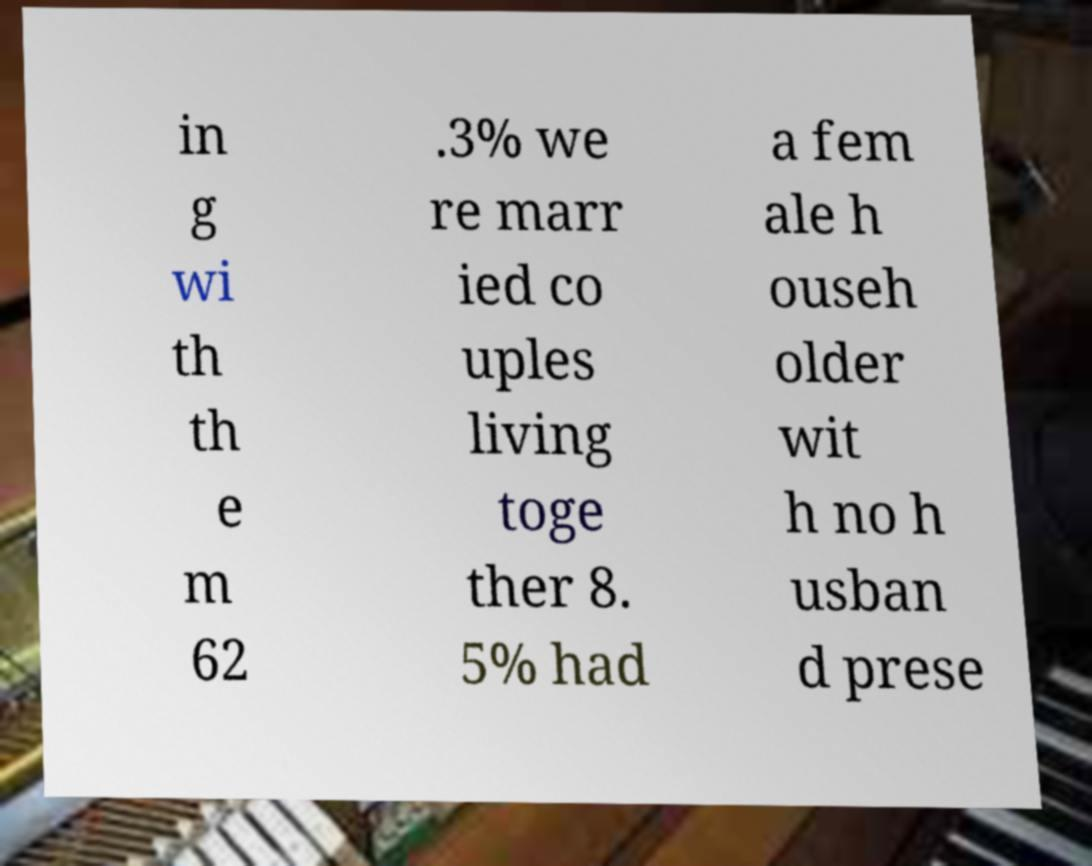Can you accurately transcribe the text from the provided image for me? in g wi th th e m 62 .3% we re marr ied co uples living toge ther 8. 5% had a fem ale h ouseh older wit h no h usban d prese 